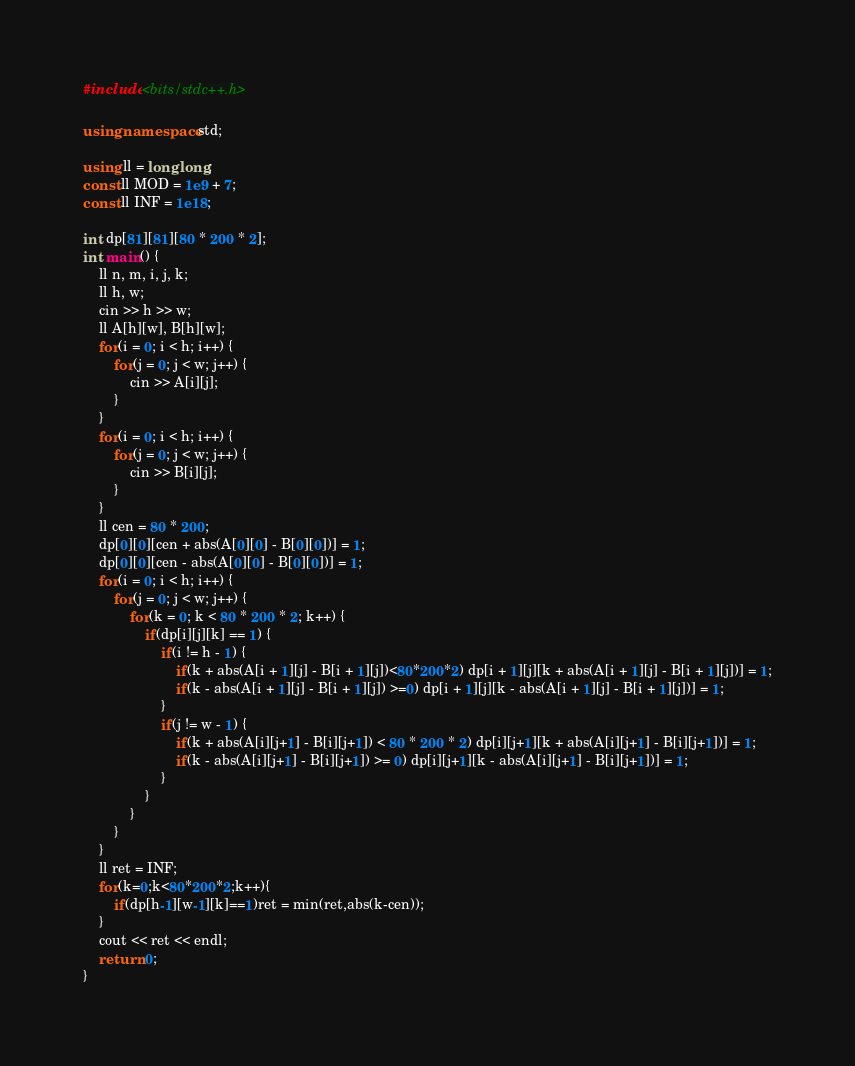<code> <loc_0><loc_0><loc_500><loc_500><_C++_>#include <bits/stdc++.h>

using namespace std;

using ll = long long;
const ll MOD = 1e9 + 7;
const ll INF = 1e18;

int dp[81][81][80 * 200 * 2];
int main() {
    ll n, m, i, j, k;
    ll h, w;
    cin >> h >> w;
    ll A[h][w], B[h][w];
    for(i = 0; i < h; i++) {
        for(j = 0; j < w; j++) {
            cin >> A[i][j];
        }
    }
    for(i = 0; i < h; i++) {
        for(j = 0; j < w; j++) {
            cin >> B[i][j];
        }
    }
    ll cen = 80 * 200;
    dp[0][0][cen + abs(A[0][0] - B[0][0])] = 1;
    dp[0][0][cen - abs(A[0][0] - B[0][0])] = 1;
    for(i = 0; i < h; i++) {
        for(j = 0; j < w; j++) {
            for(k = 0; k < 80 * 200 * 2; k++) {
                if(dp[i][j][k] == 1) {
                    if(i != h - 1) {
                        if(k + abs(A[i + 1][j] - B[i + 1][j])<80*200*2) dp[i + 1][j][k + abs(A[i + 1][j] - B[i + 1][j])] = 1;
                        if(k - abs(A[i + 1][j] - B[i + 1][j]) >=0) dp[i + 1][j][k - abs(A[i + 1][j] - B[i + 1][j])] = 1;
                    }
                    if(j != w - 1) {
                        if(k + abs(A[i][j+1] - B[i][j+1]) < 80 * 200 * 2) dp[i][j+1][k + abs(A[i][j+1] - B[i][j+1])] = 1;
                        if(k - abs(A[i][j+1] - B[i][j+1]) >= 0) dp[i][j+1][k - abs(A[i][j+1] - B[i][j+1])] = 1;
                    }
                }
            }
        }
    }
    ll ret = INF;
    for(k=0;k<80*200*2;k++){
        if(dp[h-1][w-1][k]==1)ret = min(ret,abs(k-cen));
    }
    cout << ret << endl;
    return 0;
}</code> 